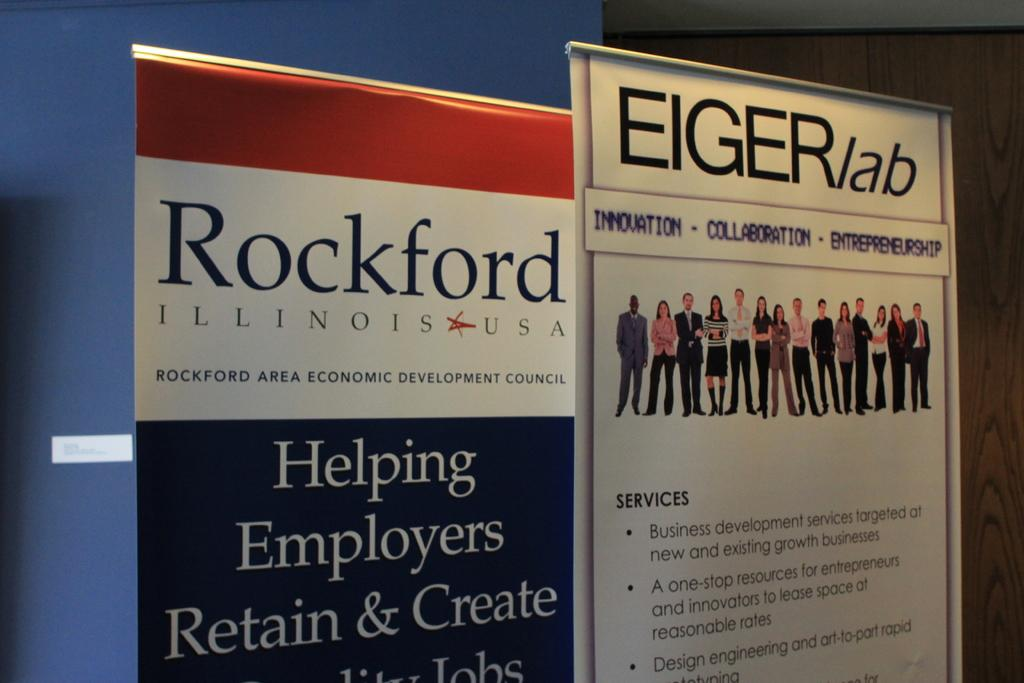What can be seen hanging in the image? There are two banners in the image. What color is the wall behind the banners? There is a blue wall in the image. Where is the door located in the image? The door is at the right back of the image. What type of plastic is being used to create an attraction in the image? There is no plastic or attraction present in the image. What operation is being performed on the door in the image? There is no operation being performed on the door in the image; it is simply a door in the background. 